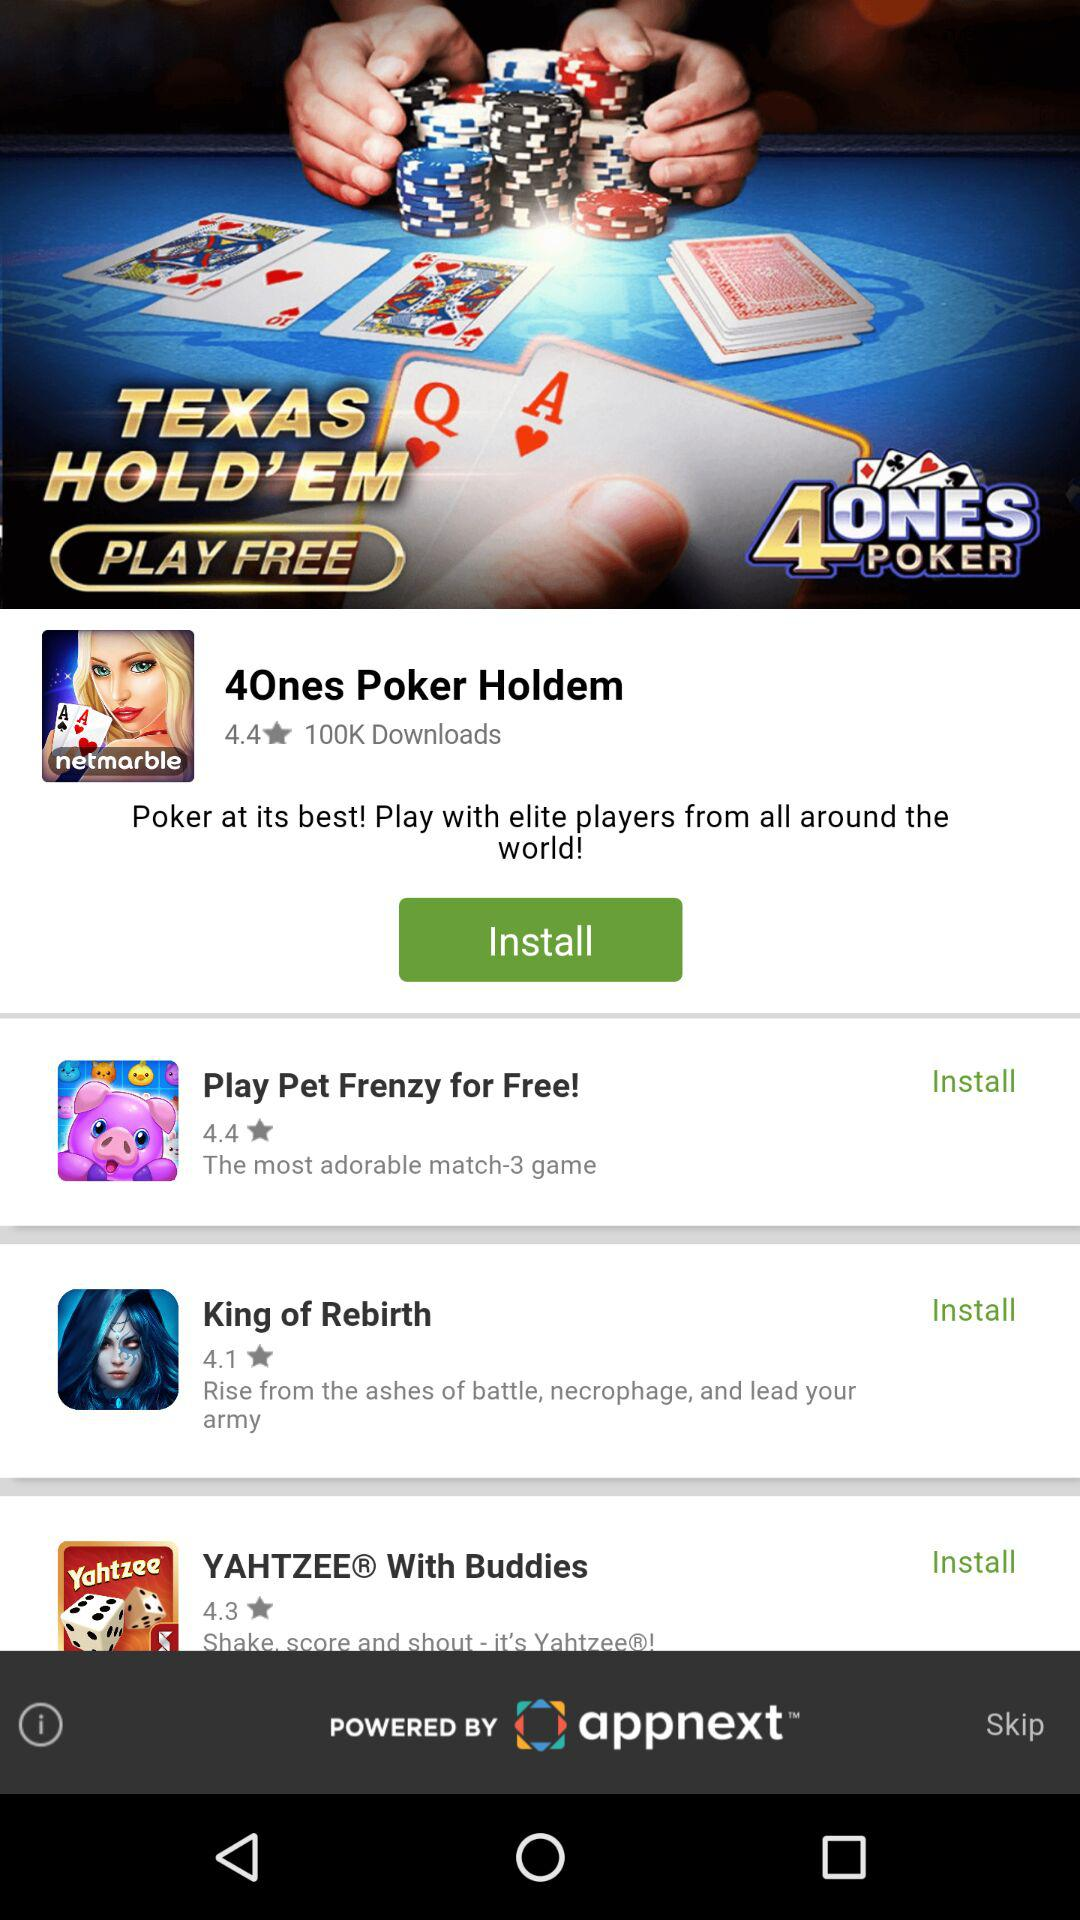How many downloads are there for "4Ones Poker Holdem"? There are 100K downloads for "4Ones Poker Holdem". 